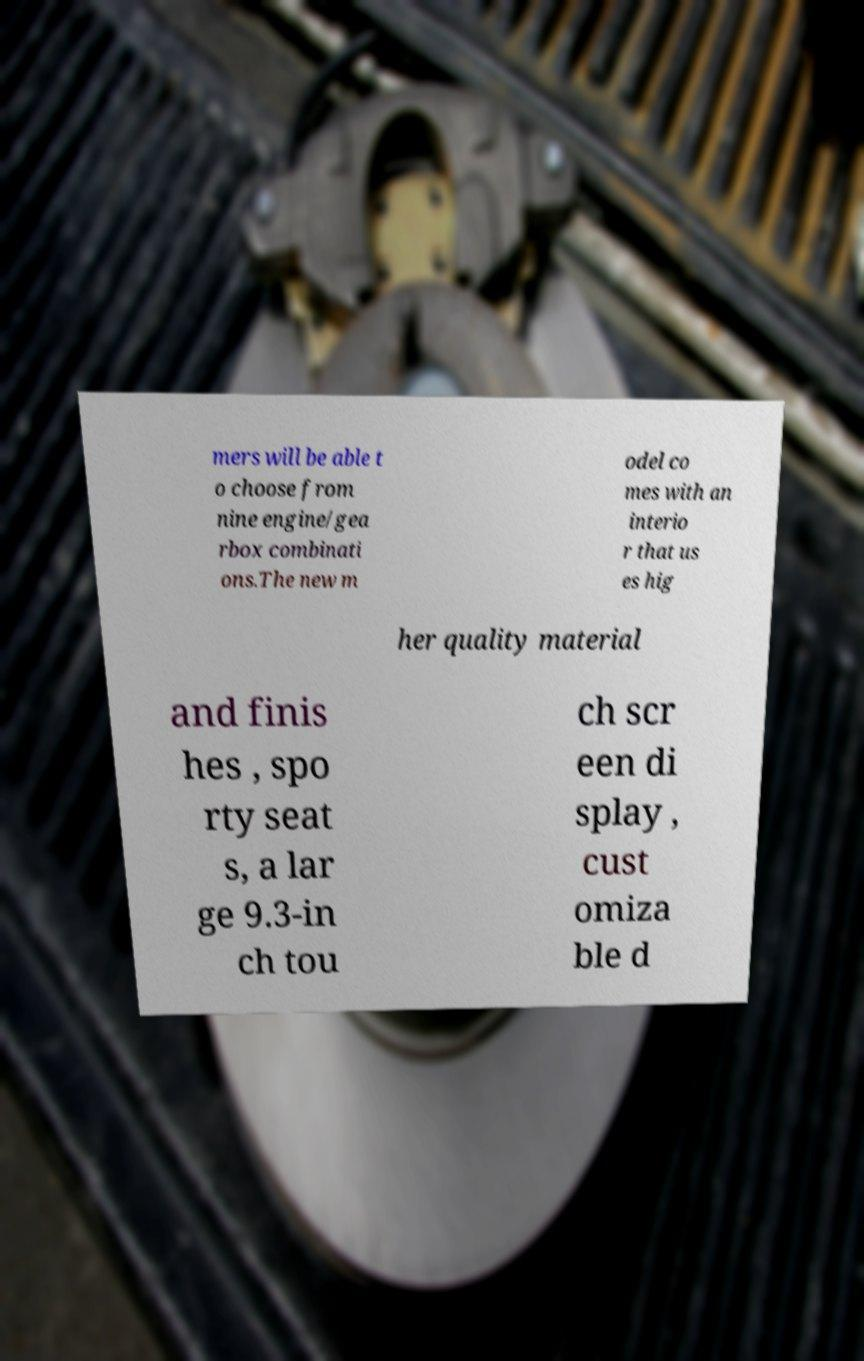Please identify and transcribe the text found in this image. mers will be able t o choose from nine engine/gea rbox combinati ons.The new m odel co mes with an interio r that us es hig her quality material and finis hes , spo rty seat s, a lar ge 9.3-in ch tou ch scr een di splay , cust omiza ble d 